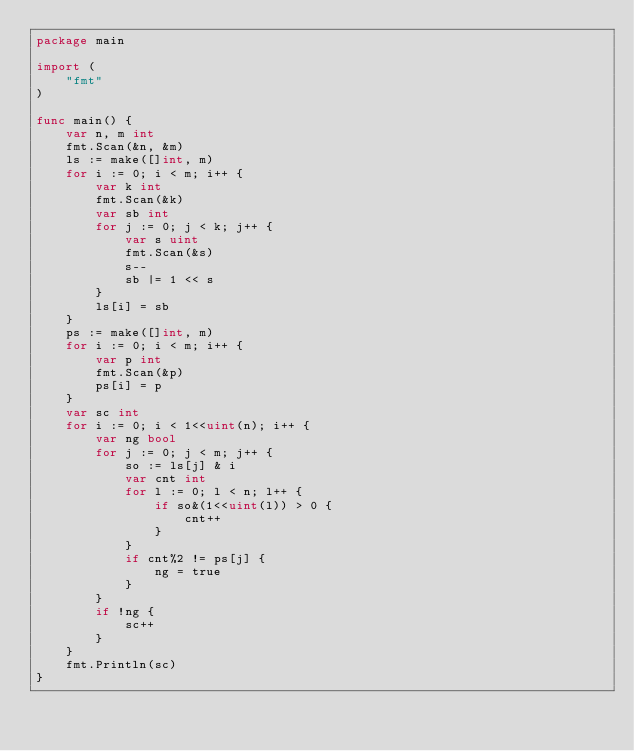<code> <loc_0><loc_0><loc_500><loc_500><_Go_>package main

import (
    "fmt"
)

func main() {
    var n, m int
    fmt.Scan(&n, &m)
    ls := make([]int, m)
    for i := 0; i < m; i++ {
        var k int
        fmt.Scan(&k)
        var sb int
        for j := 0; j < k; j++ {
            var s uint
            fmt.Scan(&s)
            s--
            sb |= 1 << s
        }
        ls[i] = sb
    }
    ps := make([]int, m)
    for i := 0; i < m; i++ {
        var p int
        fmt.Scan(&p)
        ps[i] = p
    }
    var sc int
    for i := 0; i < 1<<uint(n); i++ {
        var ng bool
        for j := 0; j < m; j++ {
            so := ls[j] & i
            var cnt int
            for l := 0; l < n; l++ {
                if so&(1<<uint(l)) > 0 {
                    cnt++
                }
            }
            if cnt%2 != ps[j] {
                ng = true
            }
        }
        if !ng {
            sc++
        }
    }
    fmt.Println(sc)
}
</code> 